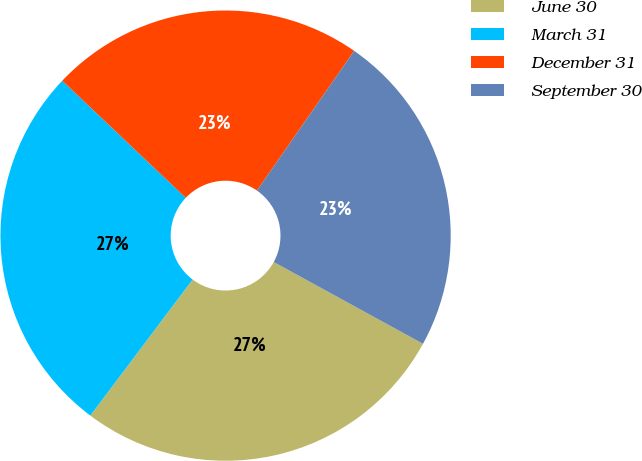<chart> <loc_0><loc_0><loc_500><loc_500><pie_chart><fcel>June 30<fcel>March 31<fcel>December 31<fcel>September 30<nl><fcel>27.28%<fcel>26.82%<fcel>22.6%<fcel>23.3%<nl></chart> 